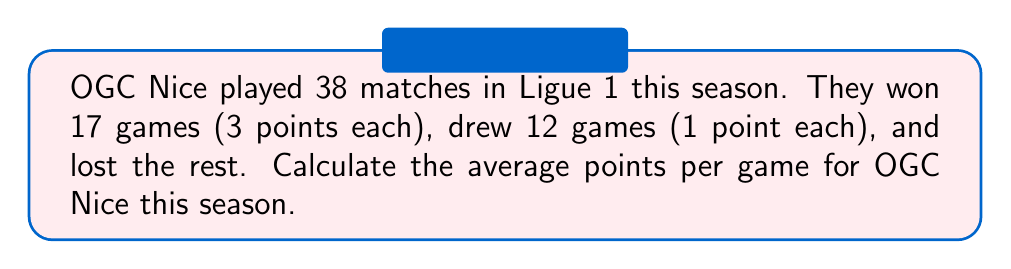Give your solution to this math problem. Let's approach this step-by-step:

1) First, let's calculate the total number of points:
   - Wins: $17 \times 3 = 51$ points
   - Draws: $12 \times 1 = 12$ points
   
2) Total points: $51 + 12 = 63$ points

3) Now, we need to calculate the average points per game:
   $$\text{Average} = \frac{\text{Total Points}}{\text{Number of Games}}$$

4) Substituting our values:
   $$\text{Average} = \frac{63}{38}$$

5) Simplifying:
   $$\text{Average} = 1.6578947368...$$

6) Rounding to two decimal places:
   $$\text{Average} \approx 1.66 \text{ points per game}$$
Answer: 1.66 points per game 